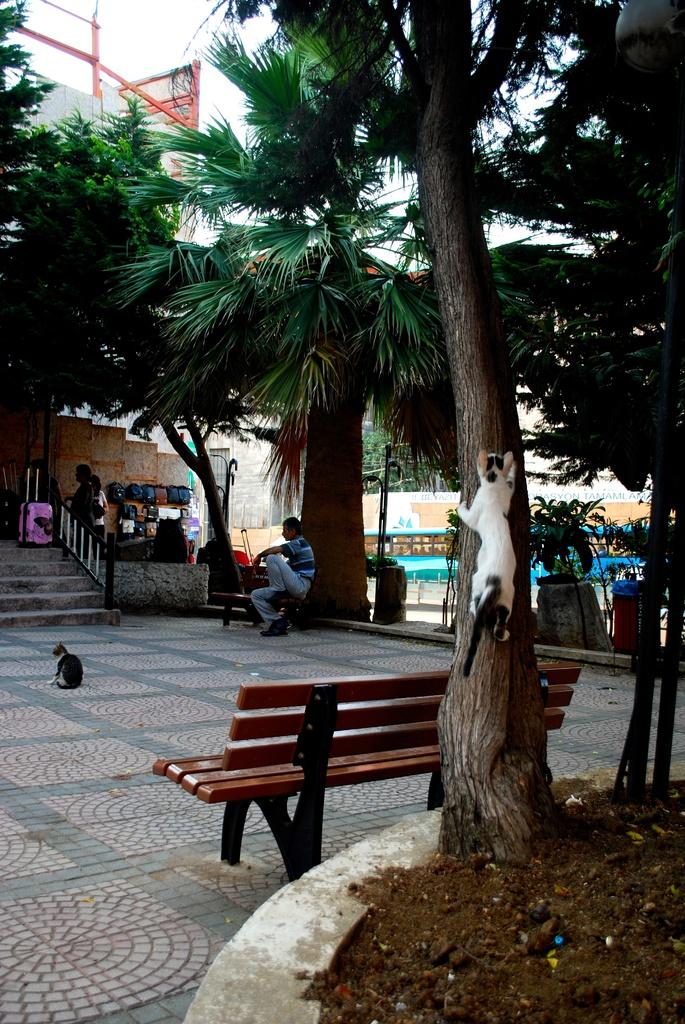What is the cat doing in the image? The cat is climbing a tree in the image. What piece of furniture is present in the image? There is a bench in the image. Who is sitting on the bench? A person is sitting on the bench. What architectural feature can be seen in the image? There are stairs in the image. What type of structure is visible in the image? There is a building in the image. How many tickets are visible in the image? There are no tickets present in the image. What type of box is being used by the cat to climb the tree? The cat is climbing the tree without the use of a box; there is no box present in the image. 